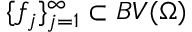<formula> <loc_0><loc_0><loc_500><loc_500>\{ f _ { j } \} _ { j = 1 } ^ { \infty } \subset B V ( \Omega )</formula> 